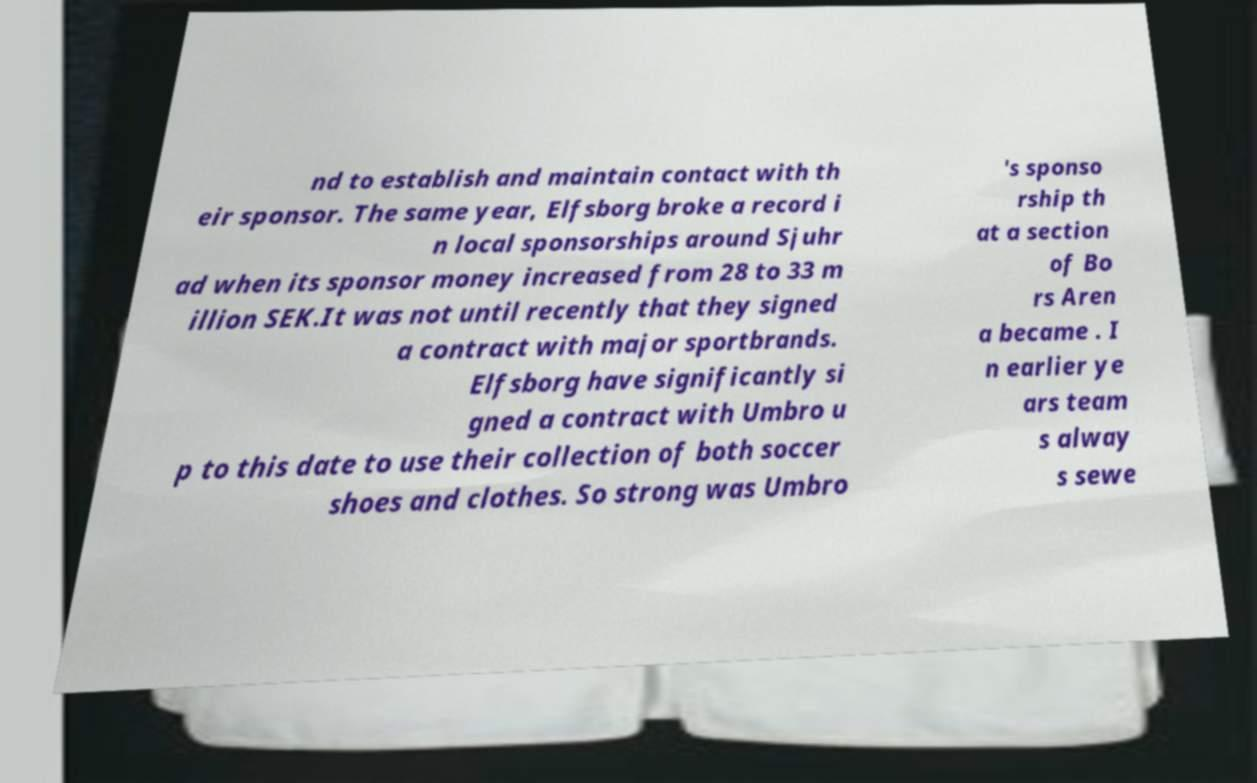Please read and relay the text visible in this image. What does it say? nd to establish and maintain contact with th eir sponsor. The same year, Elfsborg broke a record i n local sponsorships around Sjuhr ad when its sponsor money increased from 28 to 33 m illion SEK.It was not until recently that they signed a contract with major sportbrands. Elfsborg have significantly si gned a contract with Umbro u p to this date to use their collection of both soccer shoes and clothes. So strong was Umbro 's sponso rship th at a section of Bo rs Aren a became . I n earlier ye ars team s alway s sewe 